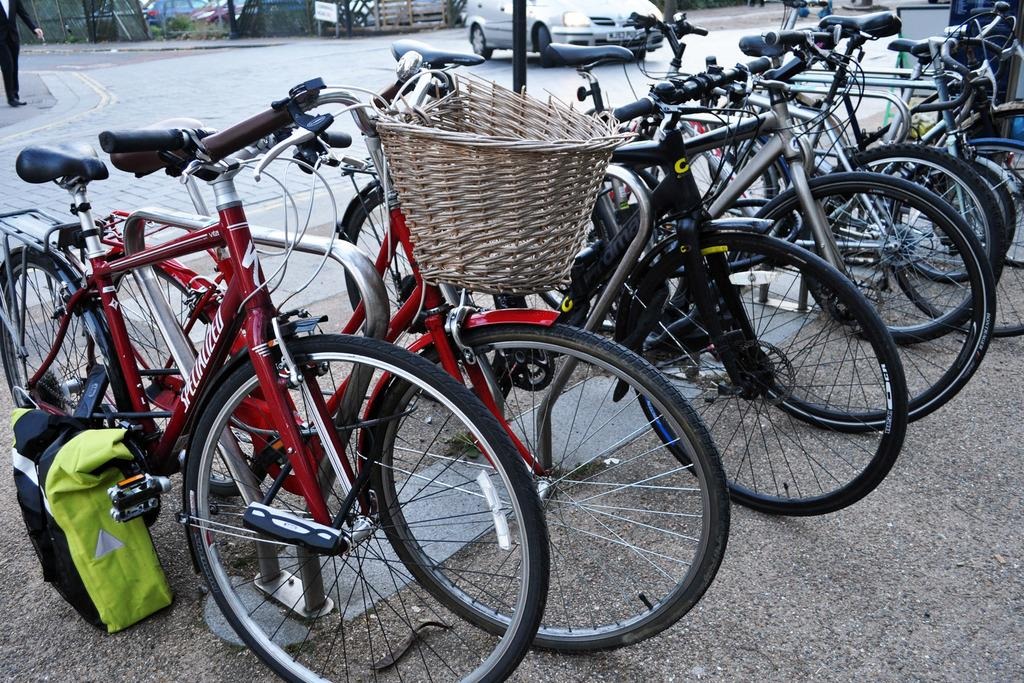What type of vehicles are parked in the image? There are bicycles parked in the image. What is happening with the car in the image? A car is moving on the road in the image. Can you describe the bicycles in more detail? There is a bag attached to one of the bicycles. What is the man in the image doing? There is a man standing on the sidewalk in the image. What type of powder is being used for breakfast in the image? There is no mention of powder or breakfast in the image; it features parked bicycles, a moving car, a bag attached to one of the bicycles, and a man standing on the sidewalk. 